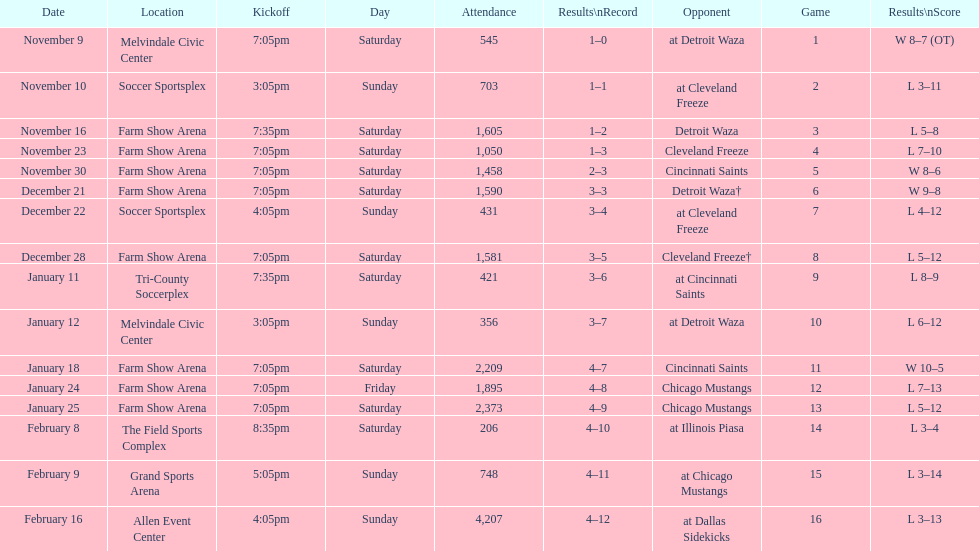Can you parse all the data within this table? {'header': ['Date', 'Location', 'Kickoff', 'Day', 'Attendance', 'Results\\nRecord', 'Opponent', 'Game', 'Results\\nScore'], 'rows': [['November 9', 'Melvindale Civic Center', '7:05pm', 'Saturday', '545', '1–0', 'at Detroit Waza', '1', 'W 8–7 (OT)'], ['November 10', 'Soccer Sportsplex', '3:05pm', 'Sunday', '703', '1–1', 'at Cleveland Freeze', '2', 'L 3–11'], ['November 16', 'Farm Show Arena', '7:35pm', 'Saturday', '1,605', '1–2', 'Detroit Waza', '3', 'L 5–8'], ['November 23', 'Farm Show Arena', '7:05pm', 'Saturday', '1,050', '1–3', 'Cleveland Freeze', '4', 'L 7–10'], ['November 30', 'Farm Show Arena', '7:05pm', 'Saturday', '1,458', '2–3', 'Cincinnati Saints', '5', 'W 8–6'], ['December 21', 'Farm Show Arena', '7:05pm', 'Saturday', '1,590', '3–3', 'Detroit Waza†', '6', 'W 9–8'], ['December 22', 'Soccer Sportsplex', '4:05pm', 'Sunday', '431', '3–4', 'at Cleveland Freeze', '7', 'L 4–12'], ['December 28', 'Farm Show Arena', '7:05pm', 'Saturday', '1,581', '3–5', 'Cleveland Freeze†', '8', 'L 5–12'], ['January 11', 'Tri-County Soccerplex', '7:35pm', 'Saturday', '421', '3–6', 'at Cincinnati Saints', '9', 'L 8–9'], ['January 12', 'Melvindale Civic Center', '3:05pm', 'Sunday', '356', '3–7', 'at Detroit Waza', '10', 'L 6–12'], ['January 18', 'Farm Show Arena', '7:05pm', 'Saturday', '2,209', '4–7', 'Cincinnati Saints', '11', 'W 10–5'], ['January 24', 'Farm Show Arena', '7:05pm', 'Friday', '1,895', '4–8', 'Chicago Mustangs', '12', 'L 7–13'], ['January 25', 'Farm Show Arena', '7:05pm', 'Saturday', '2,373', '4–9', 'Chicago Mustangs', '13', 'L 5–12'], ['February 8', 'The Field Sports Complex', '8:35pm', 'Saturday', '206', '4–10', 'at Illinois Piasa', '14', 'L 3–4'], ['February 9', 'Grand Sports Arena', '5:05pm', 'Sunday', '748', '4–11', 'at Chicago Mustangs', '15', 'L 3–14'], ['February 16', 'Allen Event Center', '4:05pm', 'Sunday', '4,207', '4–12', 'at Dallas Sidekicks', '16', 'L 3–13']]} How long was the teams longest losing streak? 5 games. 